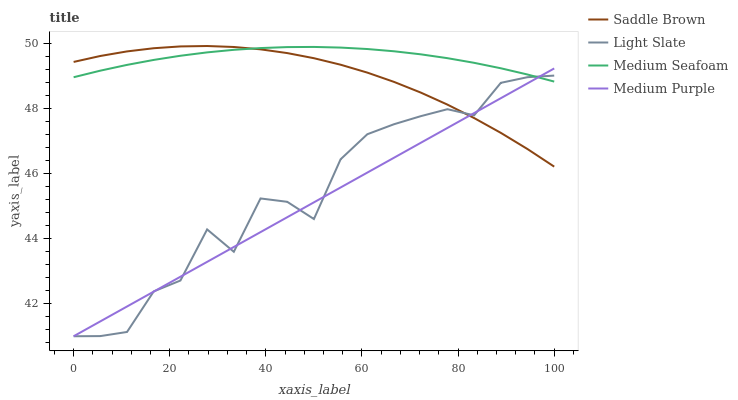Does Medium Purple have the minimum area under the curve?
Answer yes or no. Yes. Does Medium Seafoam have the maximum area under the curve?
Answer yes or no. Yes. Does Saddle Brown have the minimum area under the curve?
Answer yes or no. No. Does Saddle Brown have the maximum area under the curve?
Answer yes or no. No. Is Medium Purple the smoothest?
Answer yes or no. Yes. Is Light Slate the roughest?
Answer yes or no. Yes. Is Saddle Brown the smoothest?
Answer yes or no. No. Is Saddle Brown the roughest?
Answer yes or no. No. Does Light Slate have the lowest value?
Answer yes or no. Yes. Does Saddle Brown have the lowest value?
Answer yes or no. No. Does Saddle Brown have the highest value?
Answer yes or no. Yes. Does Medium Purple have the highest value?
Answer yes or no. No. Does Medium Purple intersect Light Slate?
Answer yes or no. Yes. Is Medium Purple less than Light Slate?
Answer yes or no. No. Is Medium Purple greater than Light Slate?
Answer yes or no. No. 